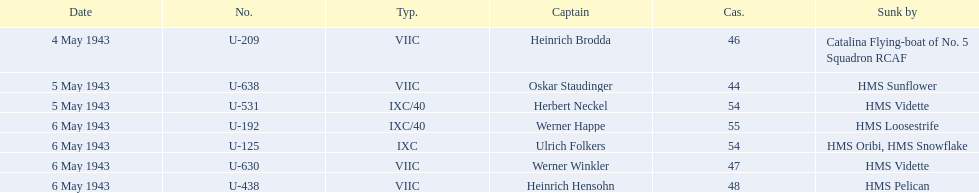What is the list of ships under sunk by? Catalina Flying-boat of No. 5 Squadron RCAF, HMS Sunflower, HMS Vidette, HMS Loosestrife, HMS Oribi, HMS Snowflake, HMS Vidette, HMS Pelican. Which captains did hms pelican sink? Heinrich Hensohn. 